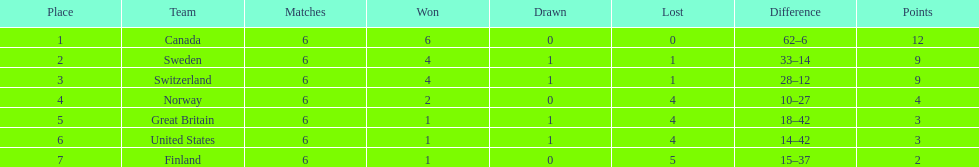After sweden, which team secured the next place? Switzerland. 